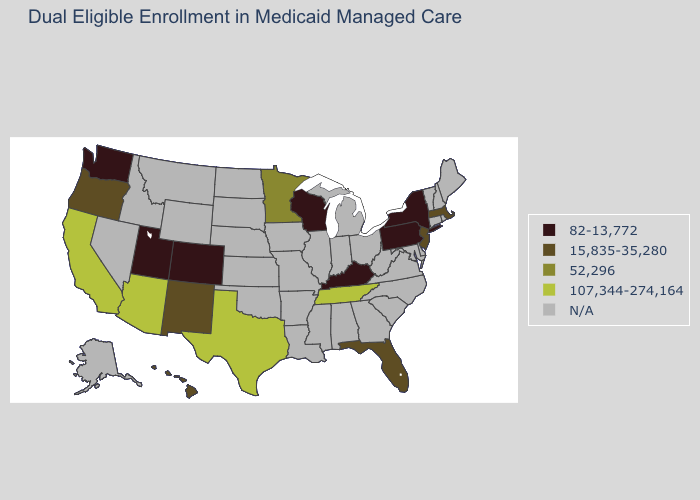Name the states that have a value in the range 107,344-274,164?
Short answer required. Arizona, California, Tennessee, Texas. What is the value of Oregon?
Quick response, please. 15,835-35,280. What is the value of Idaho?
Write a very short answer. N/A. Name the states that have a value in the range N/A?
Give a very brief answer. Alabama, Alaska, Arkansas, Connecticut, Delaware, Georgia, Idaho, Illinois, Indiana, Iowa, Kansas, Louisiana, Maine, Maryland, Michigan, Mississippi, Missouri, Montana, Nebraska, Nevada, New Hampshire, North Carolina, North Dakota, Ohio, Oklahoma, Rhode Island, South Carolina, South Dakota, Vermont, Virginia, West Virginia, Wyoming. Which states have the lowest value in the USA?
Quick response, please. Colorado, Kentucky, New York, Pennsylvania, Utah, Washington, Wisconsin. What is the lowest value in the USA?
Concise answer only. 82-13,772. Name the states that have a value in the range 52,296?
Write a very short answer. Minnesota. Name the states that have a value in the range 52,296?
Concise answer only. Minnesota. What is the value of California?
Answer briefly. 107,344-274,164. What is the value of Texas?
Give a very brief answer. 107,344-274,164. Does California have the highest value in the USA?
Keep it brief. Yes. What is the value of Washington?
Answer briefly. 82-13,772. Does Texas have the highest value in the USA?
Give a very brief answer. Yes. How many symbols are there in the legend?
Quick response, please. 5. What is the highest value in states that border Indiana?
Short answer required. 82-13,772. 